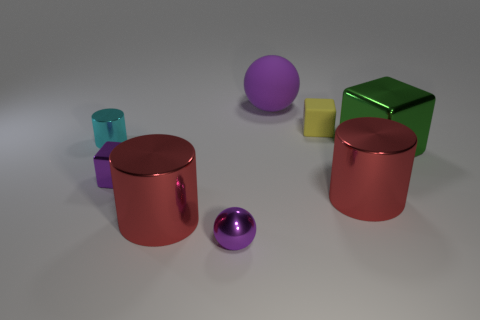Are there any tiny purple spheres to the left of the green shiny block?
Your answer should be compact. Yes. What material is the object that is both behind the small cylinder and in front of the large purple thing?
Provide a short and direct response. Rubber. Is the tiny block that is right of the metal ball made of the same material as the large ball?
Offer a terse response. Yes. What is the tiny purple ball made of?
Your answer should be very brief. Metal. How big is the purple shiny thing that is left of the tiny purple metallic ball?
Your answer should be very brief. Small. Is there anything else of the same color as the tiny cylinder?
Ensure brevity in your answer.  No. There is a purple metallic thing that is to the right of the small block that is in front of the cyan thing; are there any objects to the right of it?
Give a very brief answer. Yes. There is a sphere in front of the tiny cylinder; does it have the same color as the small metallic block?
Provide a short and direct response. Yes. How many cylinders are either red metal objects or small purple objects?
Your answer should be compact. 2. There is a large red thing that is right of the block behind the green block; what shape is it?
Make the answer very short. Cylinder. 